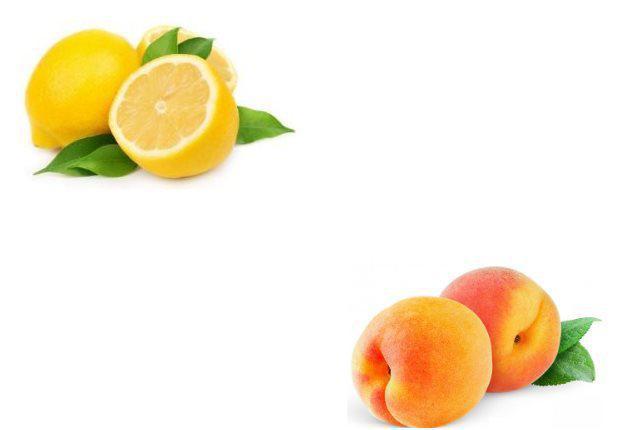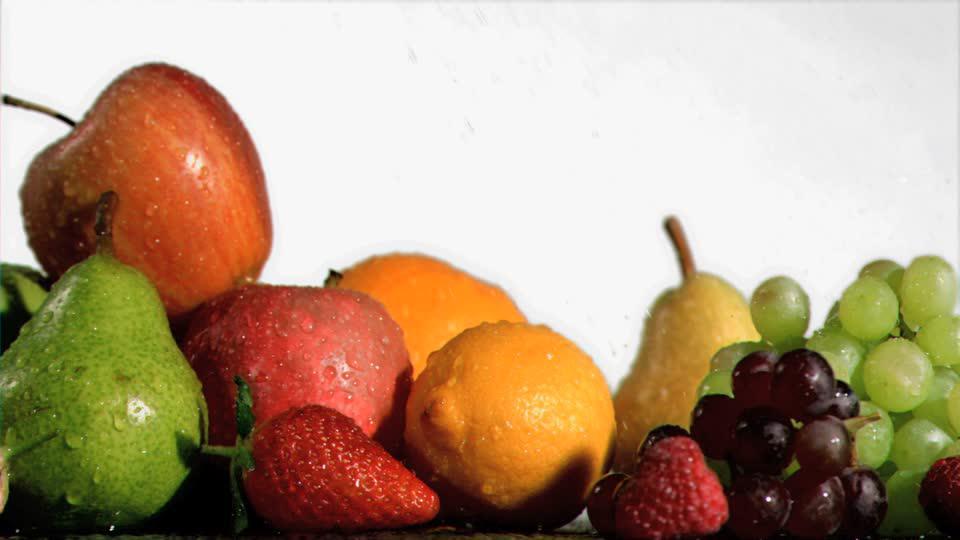The first image is the image on the left, the second image is the image on the right. Assess this claim about the two images: "Exactly one fruit is sliced in half in one of the images.". Correct or not? Answer yes or no. Yes. The first image is the image on the left, the second image is the image on the right. Given the left and right images, does the statement "An image contains two intact peaches, plus a whole lemon next to part of a lemon." hold true? Answer yes or no. Yes. 